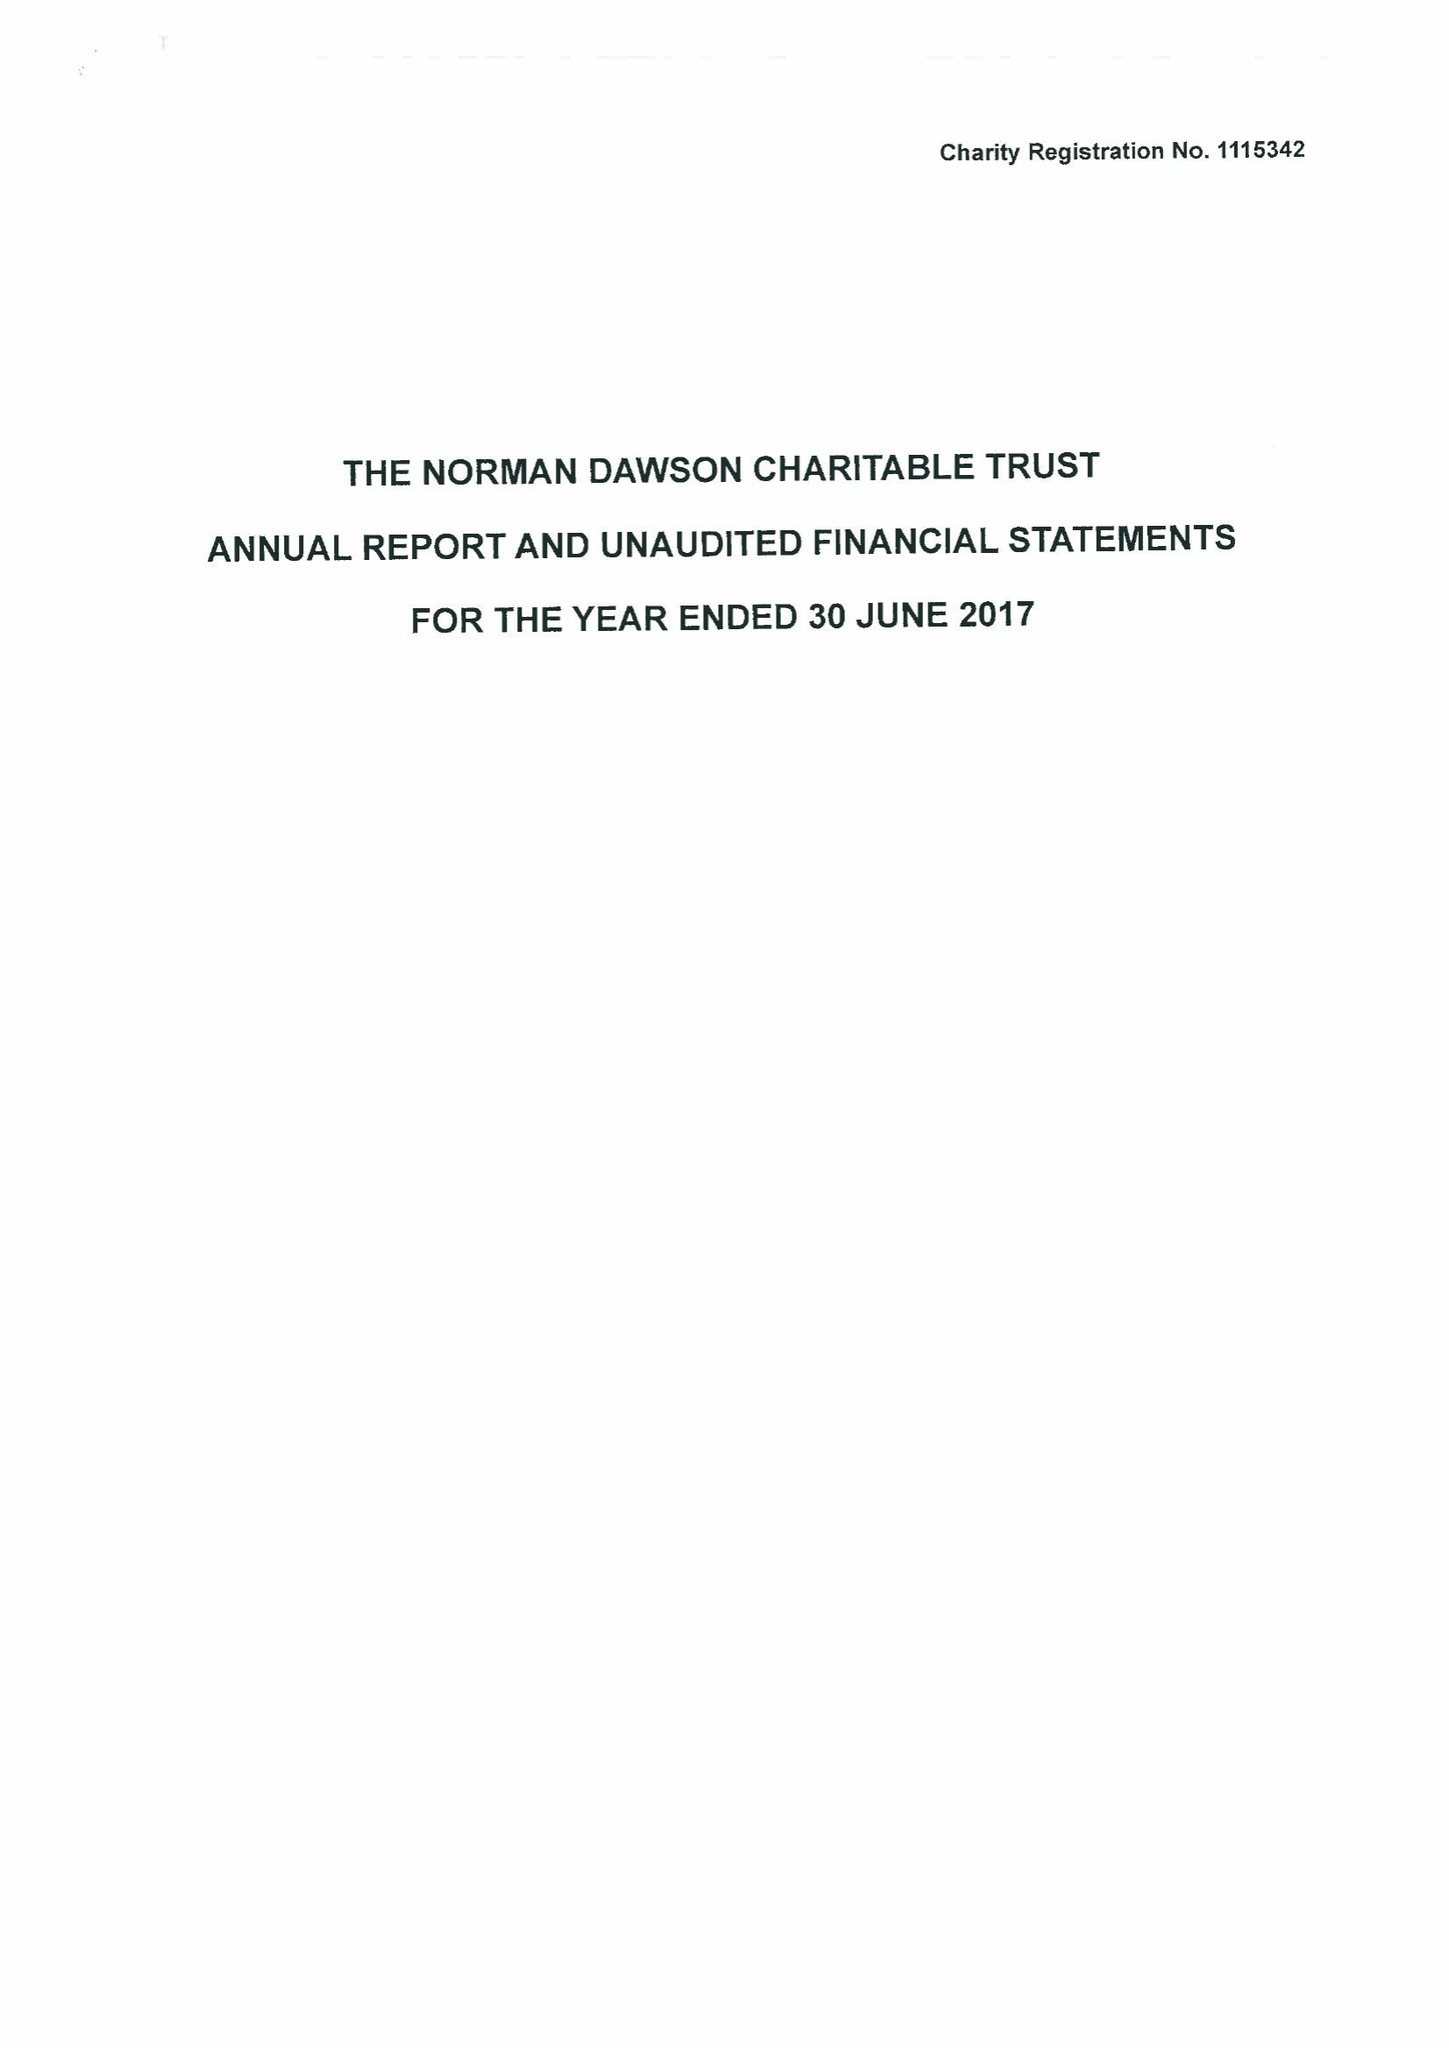What is the value for the report_date?
Answer the question using a single word or phrase. 2017-06-30 